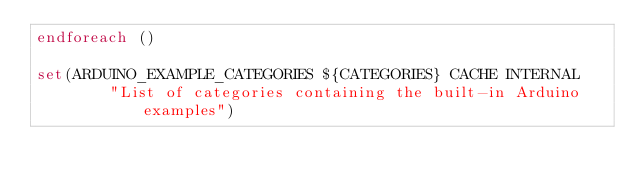Convert code to text. <code><loc_0><loc_0><loc_500><loc_500><_CMake_>endforeach ()

set(ARDUINO_EXAMPLE_CATEGORIES ${CATEGORIES} CACHE INTERNAL
        "List of categories containing the built-in Arduino examples")
</code> 